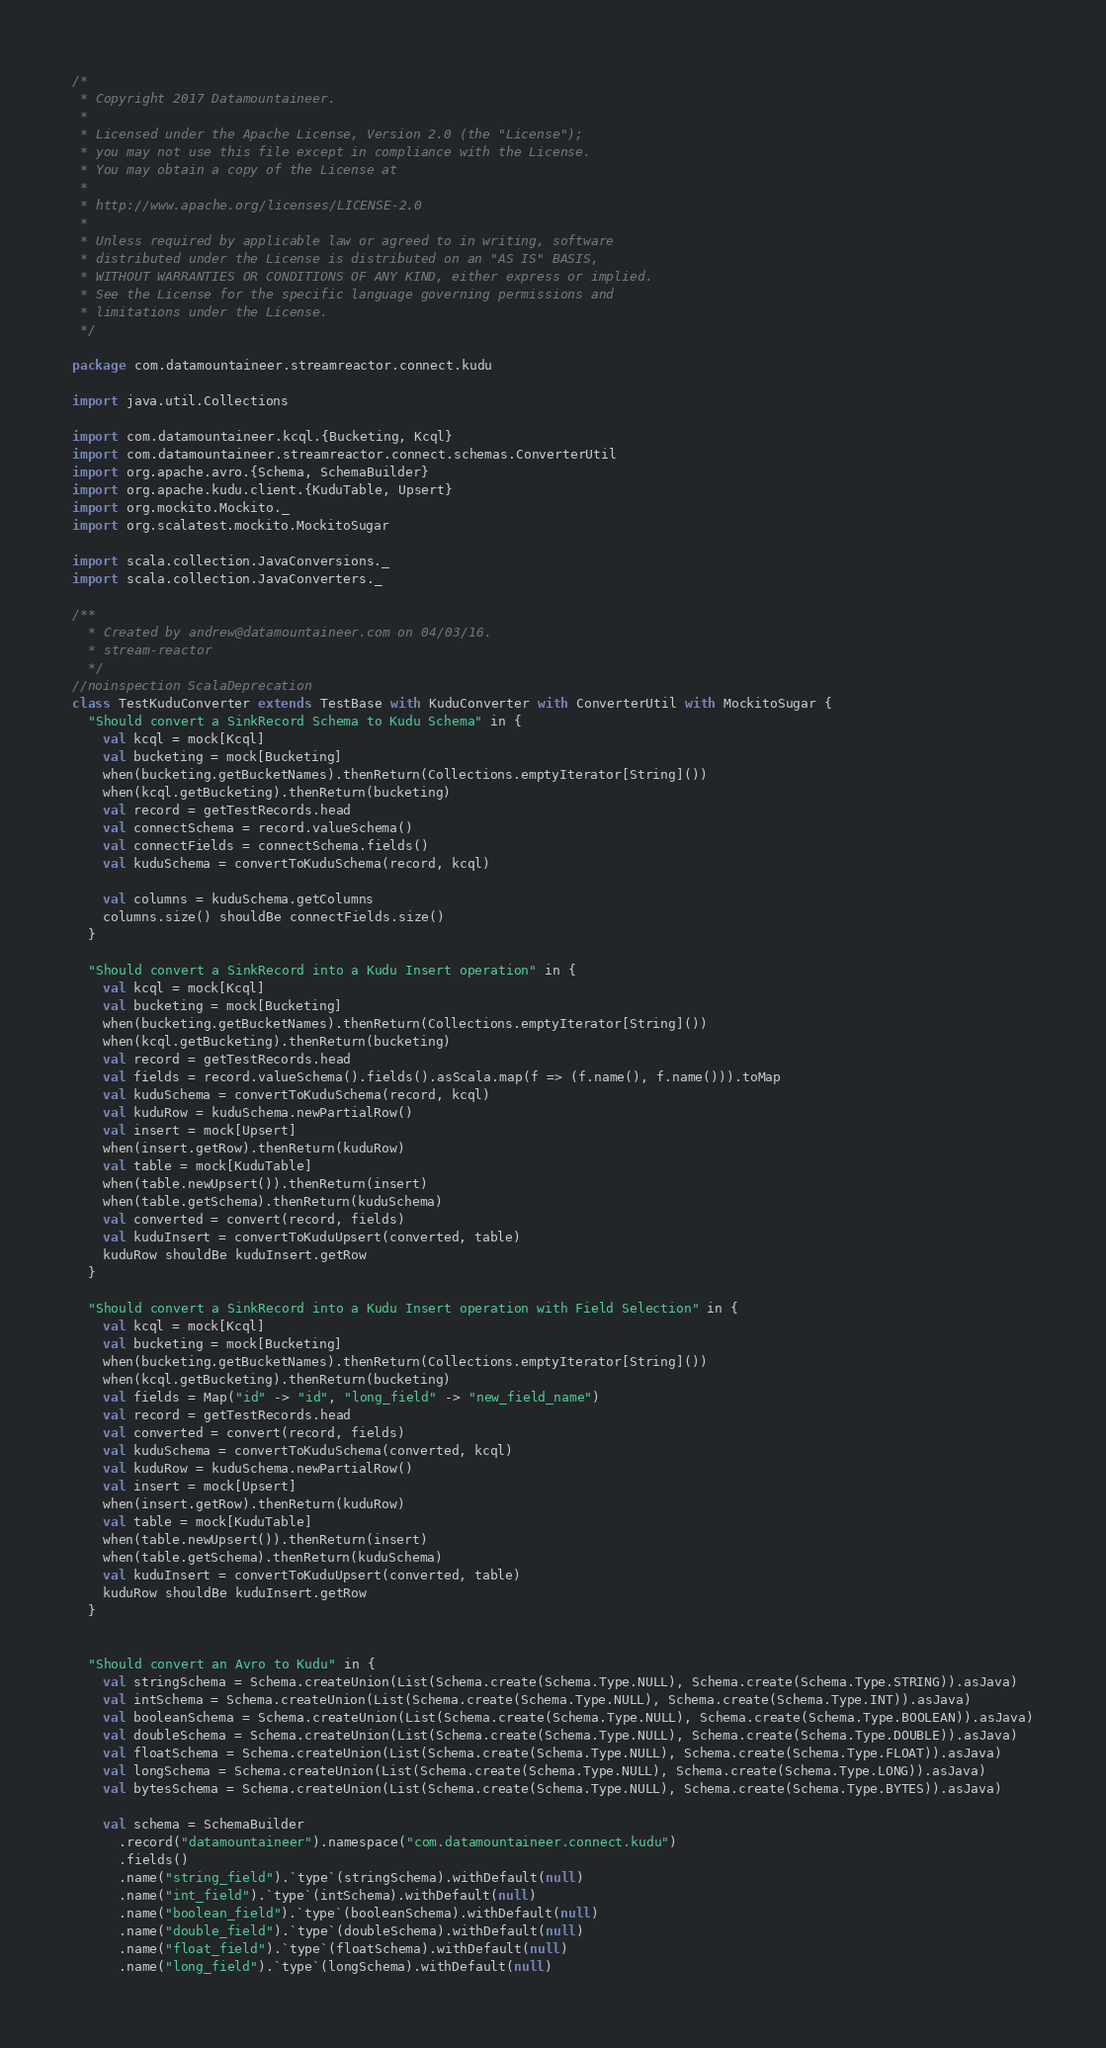<code> <loc_0><loc_0><loc_500><loc_500><_Scala_>/*
 * Copyright 2017 Datamountaineer.
 *
 * Licensed under the Apache License, Version 2.0 (the "License");
 * you may not use this file except in compliance with the License.
 * You may obtain a copy of the License at
 *
 * http://www.apache.org/licenses/LICENSE-2.0
 *
 * Unless required by applicable law or agreed to in writing, software
 * distributed under the License is distributed on an "AS IS" BASIS,
 * WITHOUT WARRANTIES OR CONDITIONS OF ANY KIND, either express or implied.
 * See the License for the specific language governing permissions and
 * limitations under the License.
 */

package com.datamountaineer.streamreactor.connect.kudu

import java.util.Collections

import com.datamountaineer.kcql.{Bucketing, Kcql}
import com.datamountaineer.streamreactor.connect.schemas.ConverterUtil
import org.apache.avro.{Schema, SchemaBuilder}
import org.apache.kudu.client.{KuduTable, Upsert}
import org.mockito.Mockito._
import org.scalatest.mockito.MockitoSugar

import scala.collection.JavaConversions._
import scala.collection.JavaConverters._

/**
  * Created by andrew@datamountaineer.com on 04/03/16.
  * stream-reactor
  */
//noinspection ScalaDeprecation
class TestKuduConverter extends TestBase with KuduConverter with ConverterUtil with MockitoSugar {
  "Should convert a SinkRecord Schema to Kudu Schema" in {
    val kcql = mock[Kcql]
    val bucketing = mock[Bucketing]
    when(bucketing.getBucketNames).thenReturn(Collections.emptyIterator[String]())
    when(kcql.getBucketing).thenReturn(bucketing)
    val record = getTestRecords.head
    val connectSchema = record.valueSchema()
    val connectFields = connectSchema.fields()
    val kuduSchema = convertToKuduSchema(record, kcql)

    val columns = kuduSchema.getColumns
    columns.size() shouldBe connectFields.size()
  }

  "Should convert a SinkRecord into a Kudu Insert operation" in {
    val kcql = mock[Kcql]
    val bucketing = mock[Bucketing]
    when(bucketing.getBucketNames).thenReturn(Collections.emptyIterator[String]())
    when(kcql.getBucketing).thenReturn(bucketing)
    val record = getTestRecords.head
    val fields = record.valueSchema().fields().asScala.map(f => (f.name(), f.name())).toMap
    val kuduSchema = convertToKuduSchema(record, kcql)
    val kuduRow = kuduSchema.newPartialRow()
    val insert = mock[Upsert]
    when(insert.getRow).thenReturn(kuduRow)
    val table = mock[KuduTable]
    when(table.newUpsert()).thenReturn(insert)
    when(table.getSchema).thenReturn(kuduSchema)
    val converted = convert(record, fields)
    val kuduInsert = convertToKuduUpsert(converted, table)
    kuduRow shouldBe kuduInsert.getRow
  }

  "Should convert a SinkRecord into a Kudu Insert operation with Field Selection" in {
    val kcql = mock[Kcql]
    val bucketing = mock[Bucketing]
    when(bucketing.getBucketNames).thenReturn(Collections.emptyIterator[String]())
    when(kcql.getBucketing).thenReturn(bucketing)
    val fields = Map("id" -> "id", "long_field" -> "new_field_name")
    val record = getTestRecords.head
    val converted = convert(record, fields)
    val kuduSchema = convertToKuduSchema(converted, kcql)
    val kuduRow = kuduSchema.newPartialRow()
    val insert = mock[Upsert]
    when(insert.getRow).thenReturn(kuduRow)
    val table = mock[KuduTable]
    when(table.newUpsert()).thenReturn(insert)
    when(table.getSchema).thenReturn(kuduSchema)
    val kuduInsert = convertToKuduUpsert(converted, table)
    kuduRow shouldBe kuduInsert.getRow
  }


  "Should convert an Avro to Kudu" in {
    val stringSchema = Schema.createUnion(List(Schema.create(Schema.Type.NULL), Schema.create(Schema.Type.STRING)).asJava)
    val intSchema = Schema.createUnion(List(Schema.create(Schema.Type.NULL), Schema.create(Schema.Type.INT)).asJava)
    val booleanSchema = Schema.createUnion(List(Schema.create(Schema.Type.NULL), Schema.create(Schema.Type.BOOLEAN)).asJava)
    val doubleSchema = Schema.createUnion(List(Schema.create(Schema.Type.NULL), Schema.create(Schema.Type.DOUBLE)).asJava)
    val floatSchema = Schema.createUnion(List(Schema.create(Schema.Type.NULL), Schema.create(Schema.Type.FLOAT)).asJava)
    val longSchema = Schema.createUnion(List(Schema.create(Schema.Type.NULL), Schema.create(Schema.Type.LONG)).asJava)
    val bytesSchema = Schema.createUnion(List(Schema.create(Schema.Type.NULL), Schema.create(Schema.Type.BYTES)).asJava)

    val schema = SchemaBuilder
      .record("datamountaineer").namespace("com.datamountaineer.connect.kudu")
      .fields()
      .name("string_field").`type`(stringSchema).withDefault(null)
      .name("int_field").`type`(intSchema).withDefault(null)
      .name("boolean_field").`type`(booleanSchema).withDefault(null)
      .name("double_field").`type`(doubleSchema).withDefault(null)
      .name("float_field").`type`(floatSchema).withDefault(null)
      .name("long_field").`type`(longSchema).withDefault(null)</code> 